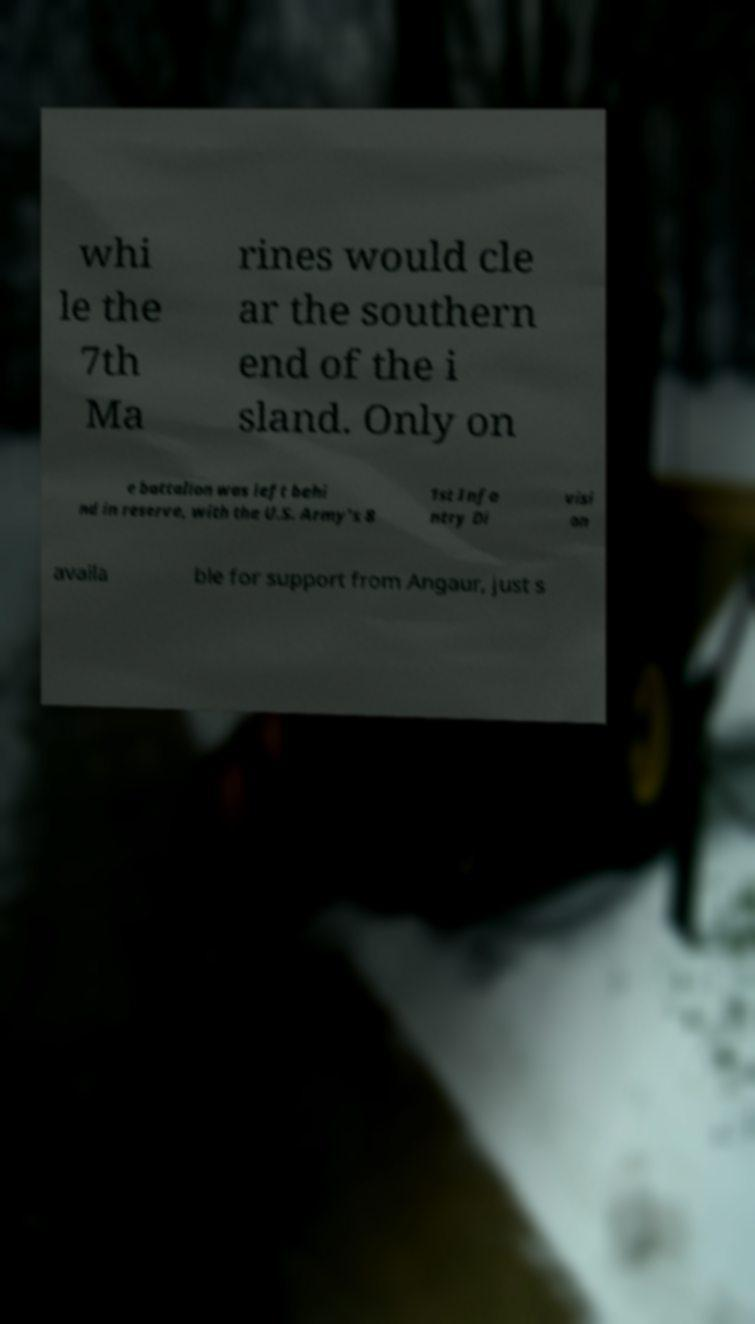Please identify and transcribe the text found in this image. whi le the 7th Ma rines would cle ar the southern end of the i sland. Only on e battalion was left behi nd in reserve, with the U.S. Army's 8 1st Infa ntry Di visi on availa ble for support from Angaur, just s 